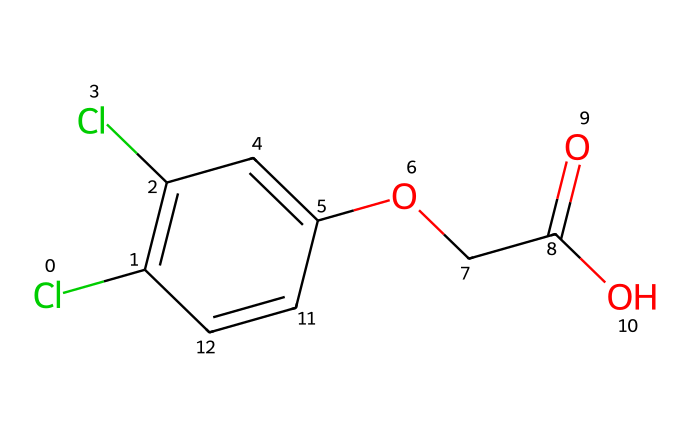What is the molecular formula of 2,4-Dichlorophenoxyacetic acid? The SMILES representation indicates the presence of 2 carbon atoms from the acetic acid part (OCC(=O)O) and several carbon atoms in the phenyl ring (C1=C(Cl)C=C(C)=C). Counting these gives a total of 8 carbons, and combining with other atoms shows the formula is C8H6Cl2O3.
Answer: C8H6Cl2O3 How many chlorine atoms are present in this molecule? The SMILES representation shows 'Cl' twice in the structure, indicating there are two chlorine atoms attached to the phenyl ring part of the molecule.
Answer: 2 What functional groups are present in 2,4-D? The SMILES shows a carboxylic acid group (OCC(=O)O), as indicated by the (C(=O)O) portion, and an ether linkage with (O) connected to (C). The presence of these characteristics establishes that both functional groups are part of the molecule.
Answer: carboxylic acid and ether Which part of the molecule is responsible for its herbicide properties? The structure primarily consists of the phenyl ring (C1=C(Cl)C=C), linked to the acetic acid part, which resembles natural plant hormones called auxins. This structural configuration mimics the action of those hormones, leading to its herbicidal properties.
Answer: phenyl ring What is the total number of double bonds in 2,4-D? Examining the SMILES structure, there are two occurrences of the '=' sign, which indicates there are two double bonds present in the molecule. They are found in the aromatic ring of the compound.
Answer: 2 How many oxygen atoms are there in 2,4-Dichlorophenoxyacetic acid? The representation shows three 'O' present in the acetic acid group and in the ether part while counting clearly from the section O and O, we find that there are a total of three oxygen atoms in the molecule.
Answer: 3 